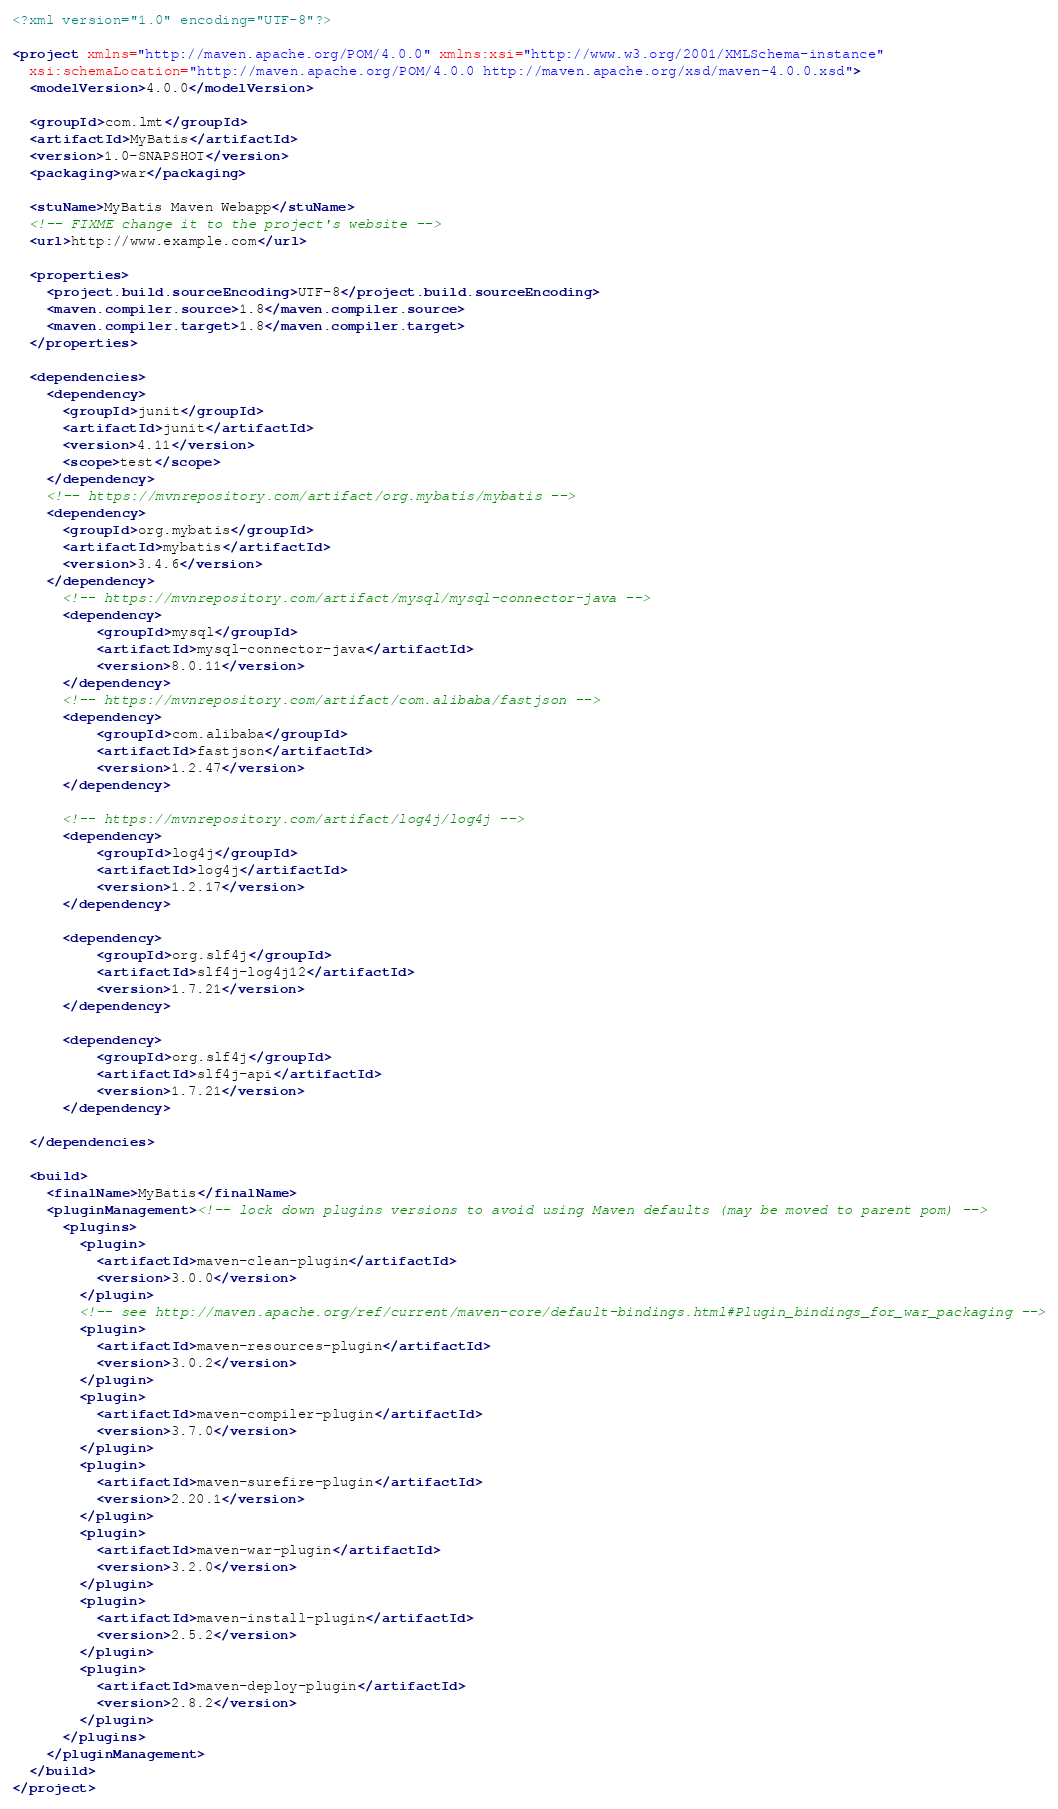<code> <loc_0><loc_0><loc_500><loc_500><_XML_><?xml version="1.0" encoding="UTF-8"?>

<project xmlns="http://maven.apache.org/POM/4.0.0" xmlns:xsi="http://www.w3.org/2001/XMLSchema-instance"
  xsi:schemaLocation="http://maven.apache.org/POM/4.0.0 http://maven.apache.org/xsd/maven-4.0.0.xsd">
  <modelVersion>4.0.0</modelVersion>

  <groupId>com.lmt</groupId>
  <artifactId>MyBatis</artifactId>
  <version>1.0-SNAPSHOT</version>
  <packaging>war</packaging>

  <stuName>MyBatis Maven Webapp</stuName>
  <!-- FIXME change it to the project's website -->
  <url>http://www.example.com</url>

  <properties>
    <project.build.sourceEncoding>UTF-8</project.build.sourceEncoding>
    <maven.compiler.source>1.8</maven.compiler.source>
    <maven.compiler.target>1.8</maven.compiler.target>
  </properties>

  <dependencies>
    <dependency>
      <groupId>junit</groupId>
      <artifactId>junit</artifactId>
      <version>4.11</version>
      <scope>test</scope>
    </dependency>
    <!-- https://mvnrepository.com/artifact/org.mybatis/mybatis -->
    <dependency>
      <groupId>org.mybatis</groupId>
      <artifactId>mybatis</artifactId>
      <version>3.4.6</version>
    </dependency>
      <!-- https://mvnrepository.com/artifact/mysql/mysql-connector-java -->
      <dependency>
          <groupId>mysql</groupId>
          <artifactId>mysql-connector-java</artifactId>
          <version>8.0.11</version>
      </dependency>
      <!-- https://mvnrepository.com/artifact/com.alibaba/fastjson -->
      <dependency>
          <groupId>com.alibaba</groupId>
          <artifactId>fastjson</artifactId>
          <version>1.2.47</version>
      </dependency>

      <!-- https://mvnrepository.com/artifact/log4j/log4j -->
      <dependency>
          <groupId>log4j</groupId>
          <artifactId>log4j</artifactId>
          <version>1.2.17</version>
      </dependency>

      <dependency>
          <groupId>org.slf4j</groupId>
          <artifactId>slf4j-log4j12</artifactId>
          <version>1.7.21</version>
      </dependency>

      <dependency>
          <groupId>org.slf4j</groupId>
          <artifactId>slf4j-api</artifactId>
          <version>1.7.21</version>
      </dependency>

  </dependencies>

  <build>
    <finalName>MyBatis</finalName>
    <pluginManagement><!-- lock down plugins versions to avoid using Maven defaults (may be moved to parent pom) -->
      <plugins>
        <plugin>
          <artifactId>maven-clean-plugin</artifactId>
          <version>3.0.0</version>
        </plugin>
        <!-- see http://maven.apache.org/ref/current/maven-core/default-bindings.html#Plugin_bindings_for_war_packaging -->
        <plugin>
          <artifactId>maven-resources-plugin</artifactId>
          <version>3.0.2</version>
        </plugin>
        <plugin>
          <artifactId>maven-compiler-plugin</artifactId>
          <version>3.7.0</version>
        </plugin>
        <plugin>
          <artifactId>maven-surefire-plugin</artifactId>
          <version>2.20.1</version>
        </plugin>
        <plugin>
          <artifactId>maven-war-plugin</artifactId>
          <version>3.2.0</version>
        </plugin>
        <plugin>
          <artifactId>maven-install-plugin</artifactId>
          <version>2.5.2</version>
        </plugin>
        <plugin>
          <artifactId>maven-deploy-plugin</artifactId>
          <version>2.8.2</version>
        </plugin>
      </plugins>
    </pluginManagement>
  </build>
</project>
</code> 